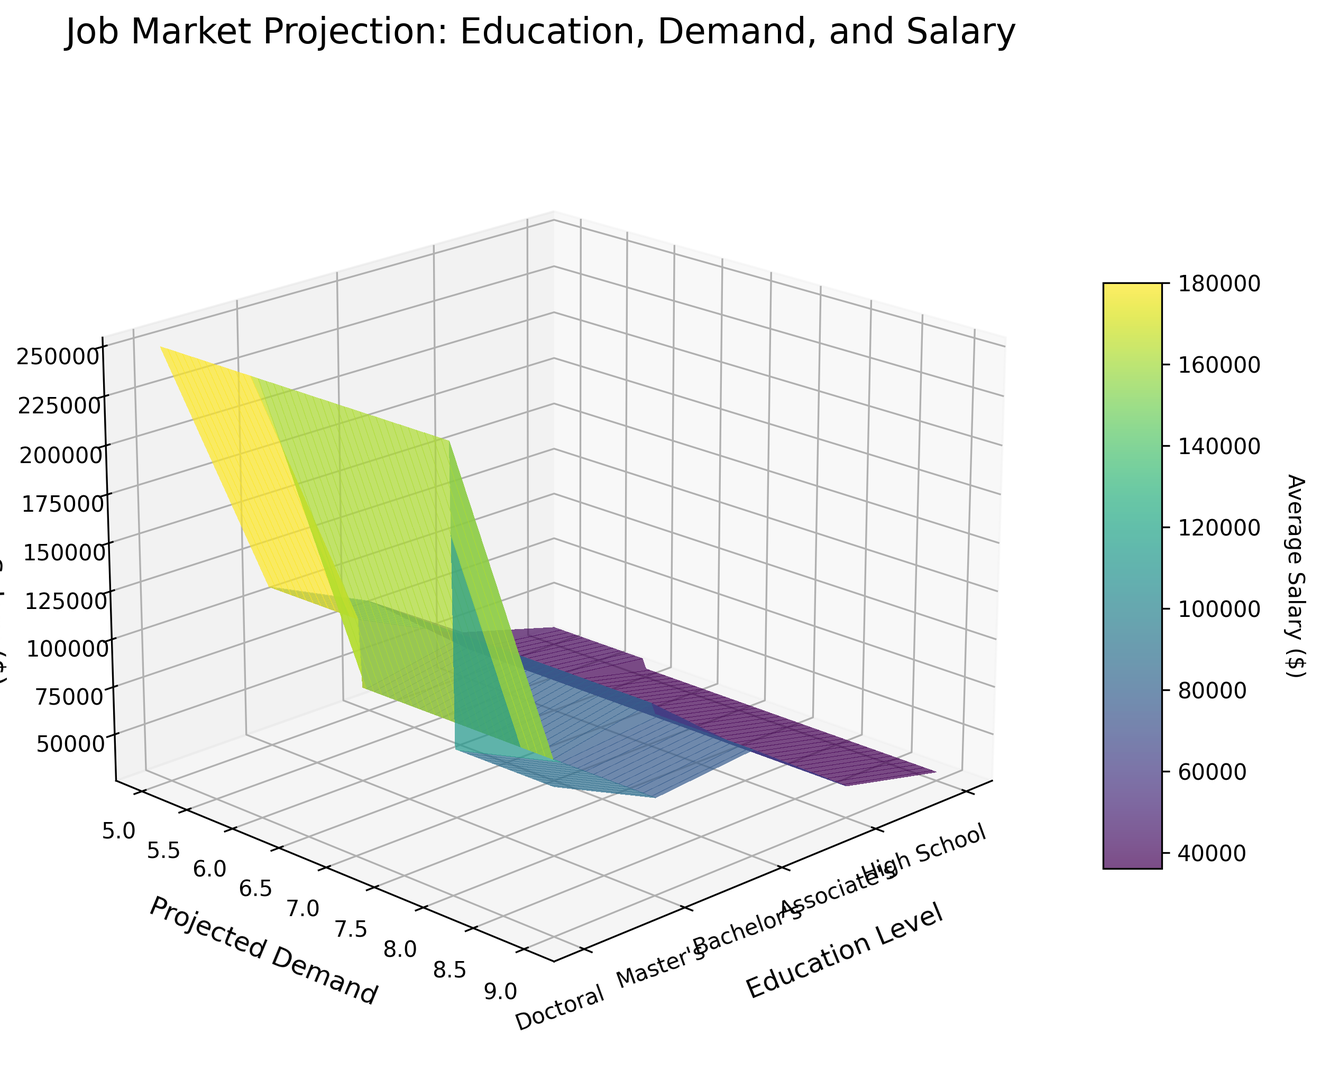Which education level has the highest average salary? By looking at the height of the Z-axis (Average Salary) for each education level, it's clear that the Doctoral level has the highest average salary.
Answer: Doctoral Which career field has the highest projected demand in the Bachelor's category? Within the Bachelor's category on the X-axis, the projected demand (Y-axis) for Software Development reaches the highest on the Z-axis among other fields.
Answer: Software Development Compare the average salaries between Master's in Data Science and Bachelor's in Software Development. Which is higher? From the figure, Master's in Data Science reaches a higher point on the Z-axis for average salary compared to Bachelor's in Software Development.
Answer: Data Science What is the visual difference in average salaries between Associate's and Bachelor's education levels for the highest demand careers? By comparing the peak Z-axis values for the highest demand careers in the Associate's and Bachelor's categories, Bachelor's category (Software Development) shows a higher average salary compared to Associate's (Healthcare Support).
Answer: Bachelor's Which education level shows the most variance in average salary with respect to projected demand? By observing the 3D surface's gradient, the Master's level shows the most visible variation in Z-axis values for different Y-axis (projected demand) measurements, indicating high variance.
Answer: Master's Is there any education level where the average salary consistently rises with increasing projected demand? For the Doctoral level, the Z-axis (salary) appears to generally increase as the Y-axis (projected demand) increases, indicating a consistent rise in salary with demand.
Answer: Doctoral Between Bachelor's in Nursing and Master's in Healthcare Administration, which offers a higher average salary? By comparing the height of the surfaces at these points, the Master's in Healthcare Administration shows a higher Z-axis (salary) than Bachelor's in Nursing.
Answer: Healthcare Administration Does a career in Retail (High School level) or Culinary Arts (Associate's level) have a higher average salary? The Z-axis (salary) for Culinary Arts in the Associate's category hits a higher point than Retail in the High School category, indicating a higher average salary.
Answer: Culinary Arts What is the difference in projected demand between Bachelor's in Education and Master's in Environmental Science? By locating both points on the Y-axis (projected demand), Education at Bachelor's level and Environmental Science at Master's level, the values can be subtracted to find the difference: Environmental Science (6) - Education (6) = 0.
Answer: The same Is there a nearly flat salary response to demand in any career field across different education levels? Observing the surface plot, the average salary for Bachelor's in Education maintains almost the same Z-axis value across varying Y-axis (projected demand) values, suggesting a flat response.
Answer: Education 